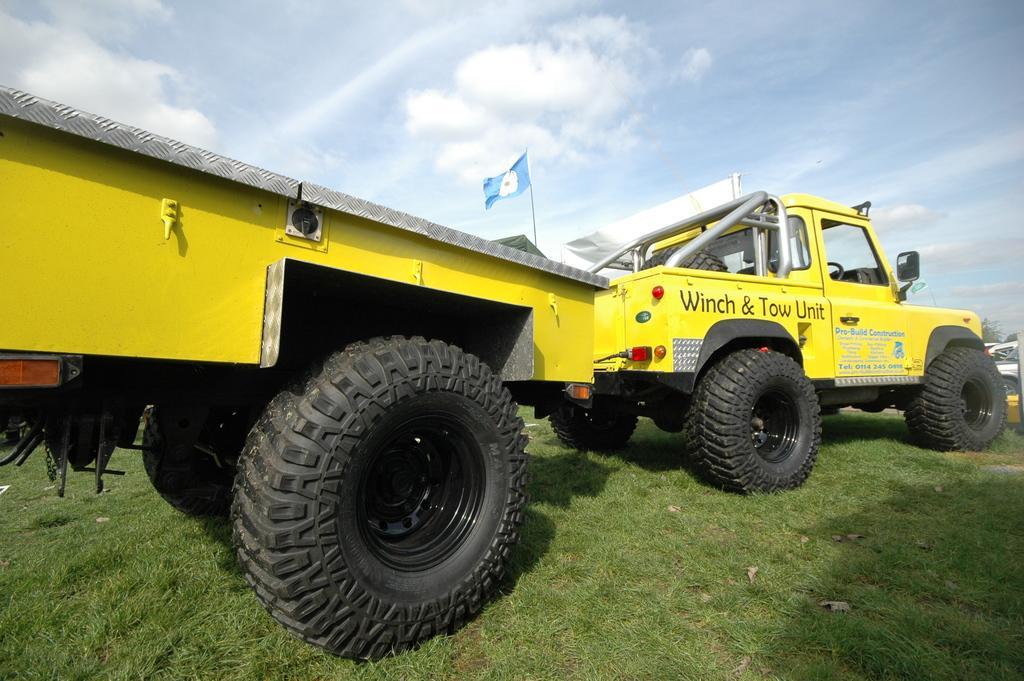In one or two sentences, can you explain what this image depicts? In this picture we can see a vehicle on the grass which is in yellow color. This is flag and on the background there is a sky with clouds. 